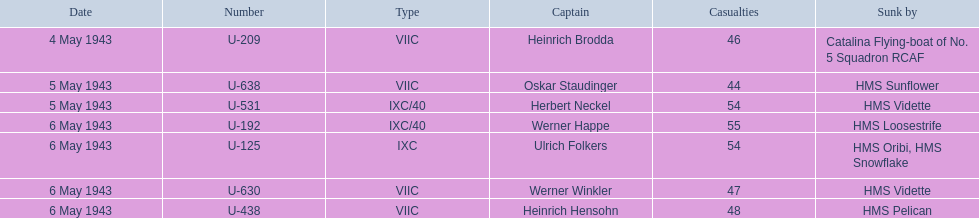Which sunken u-boat had the most casualties U-192. 